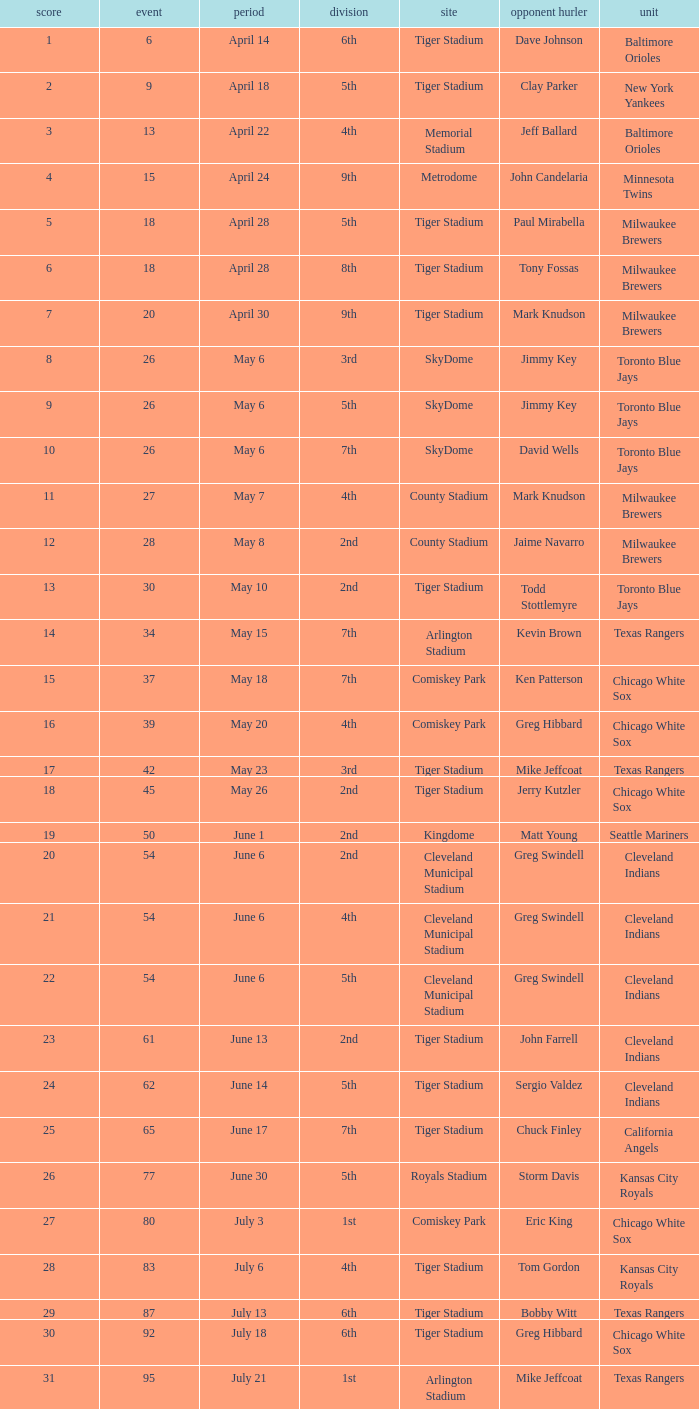What date was the game at Comiskey Park and had a 4th Inning? May 20. 